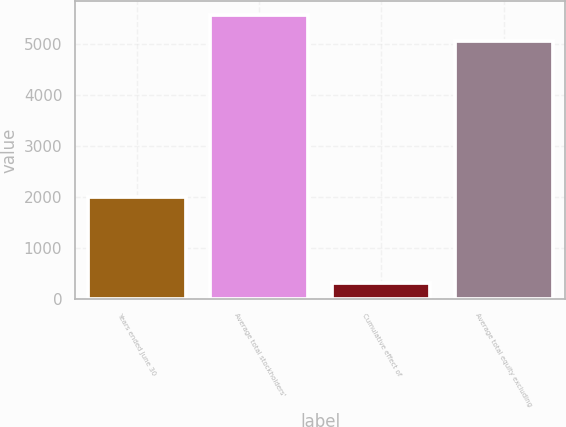Convert chart. <chart><loc_0><loc_0><loc_500><loc_500><bar_chart><fcel>Years ended June 30<fcel>Average total stockholders'<fcel>Cumulative effect of<fcel>Average total equity excluding<nl><fcel>2004<fcel>5580.3<fcel>321.6<fcel>5073<nl></chart> 